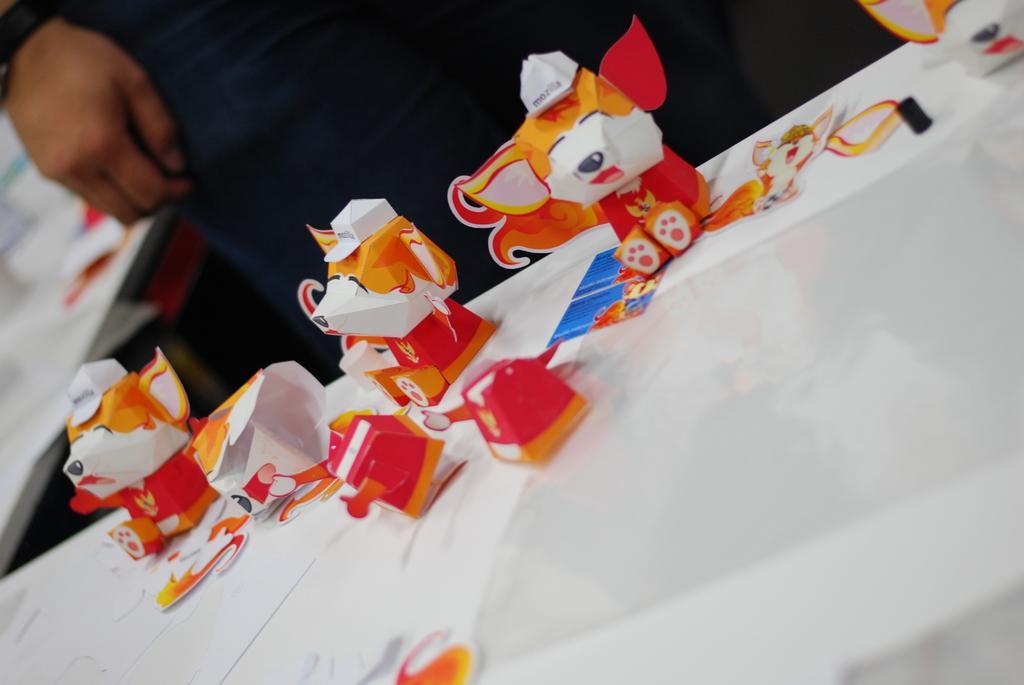Please provide a concise description of this image. This image consists of a table. On that table there are some toys. There is a person standing at the top. 